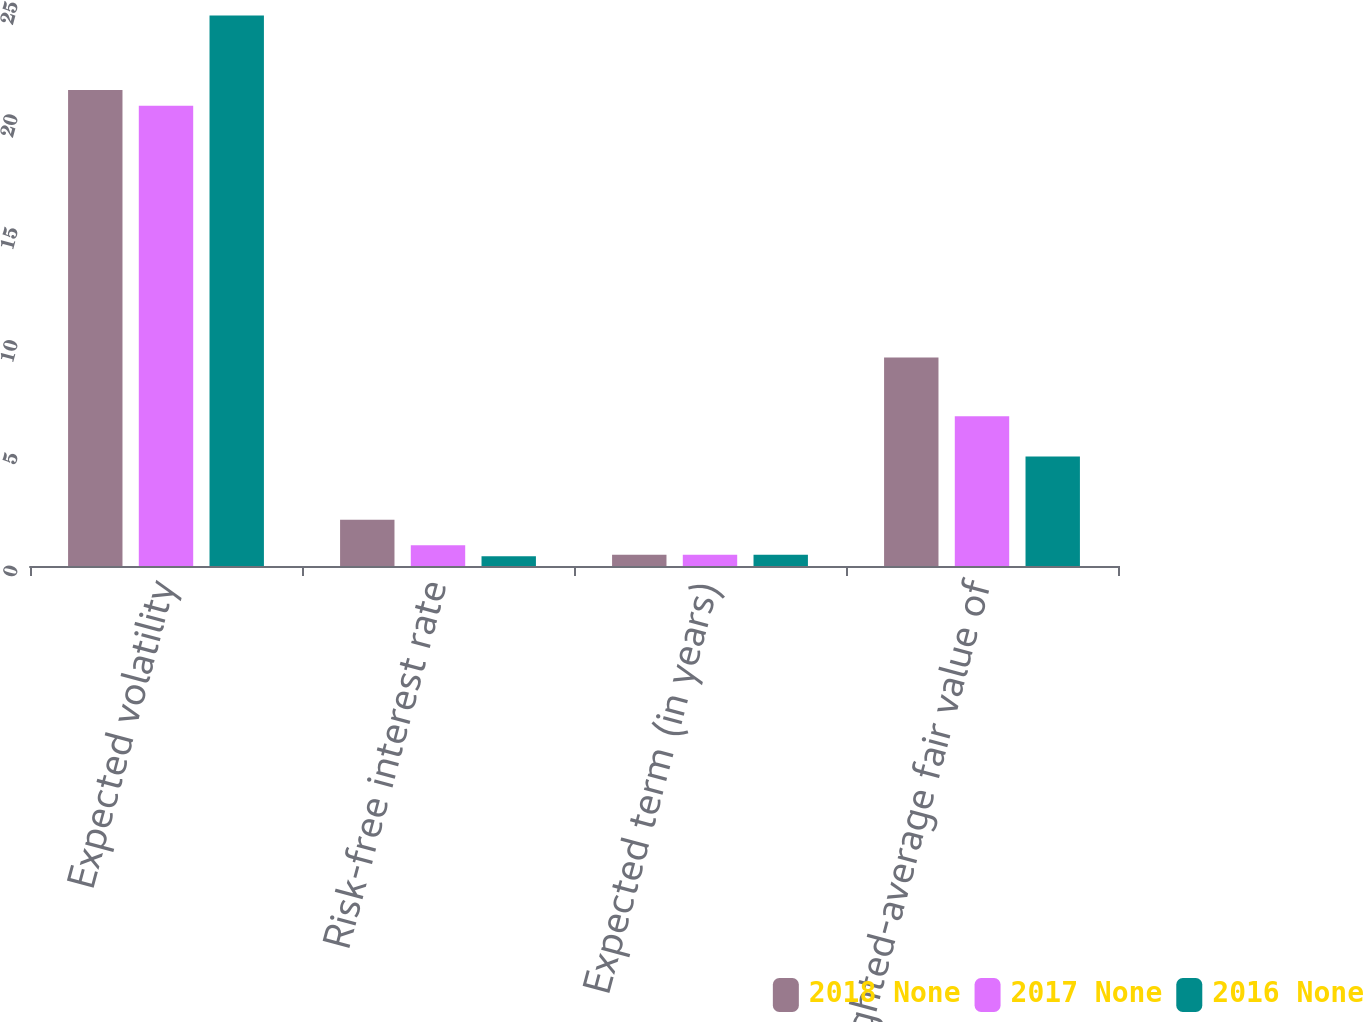Convert chart. <chart><loc_0><loc_0><loc_500><loc_500><stacked_bar_chart><ecel><fcel>Expected volatility<fcel>Risk-free interest rate<fcel>Expected term (in years)<fcel>Weighted-average fair value of<nl><fcel>2018 None<fcel>21.1<fcel>2.05<fcel>0.5<fcel>9.24<nl><fcel>2017 None<fcel>20.4<fcel>0.92<fcel>0.5<fcel>6.64<nl><fcel>2016 None<fcel>24.4<fcel>0.43<fcel>0.5<fcel>4.85<nl></chart> 